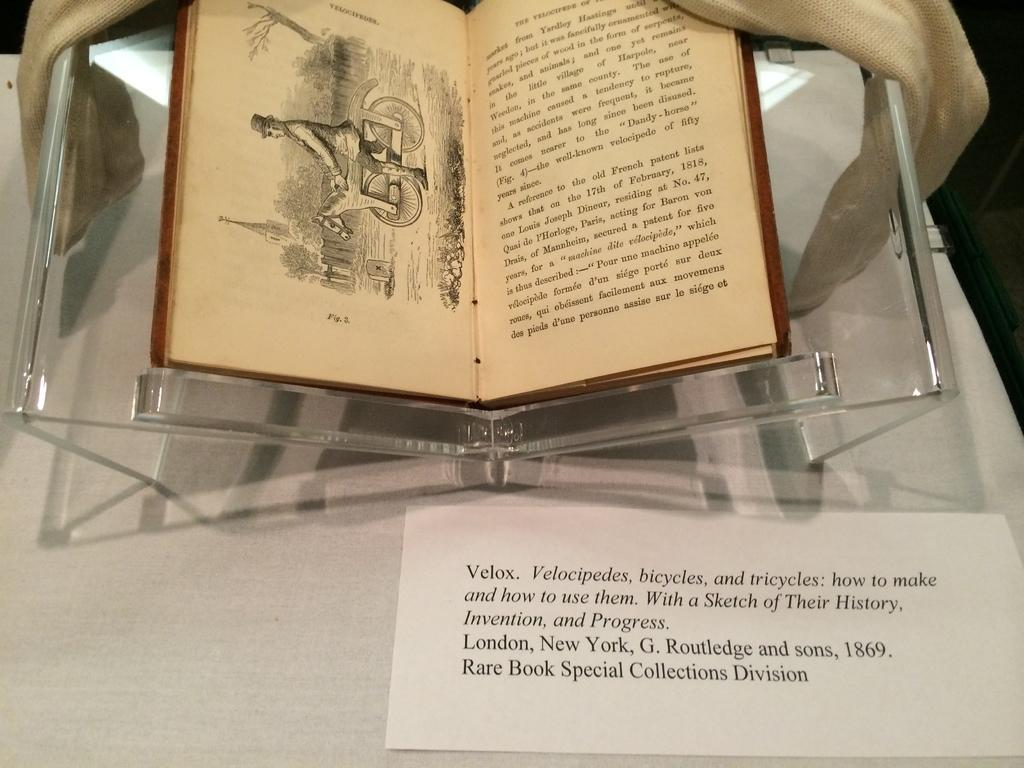<image>
Share a concise interpretation of the image provided. An old book on display about Velocipedes, bicycles, and tricycles 